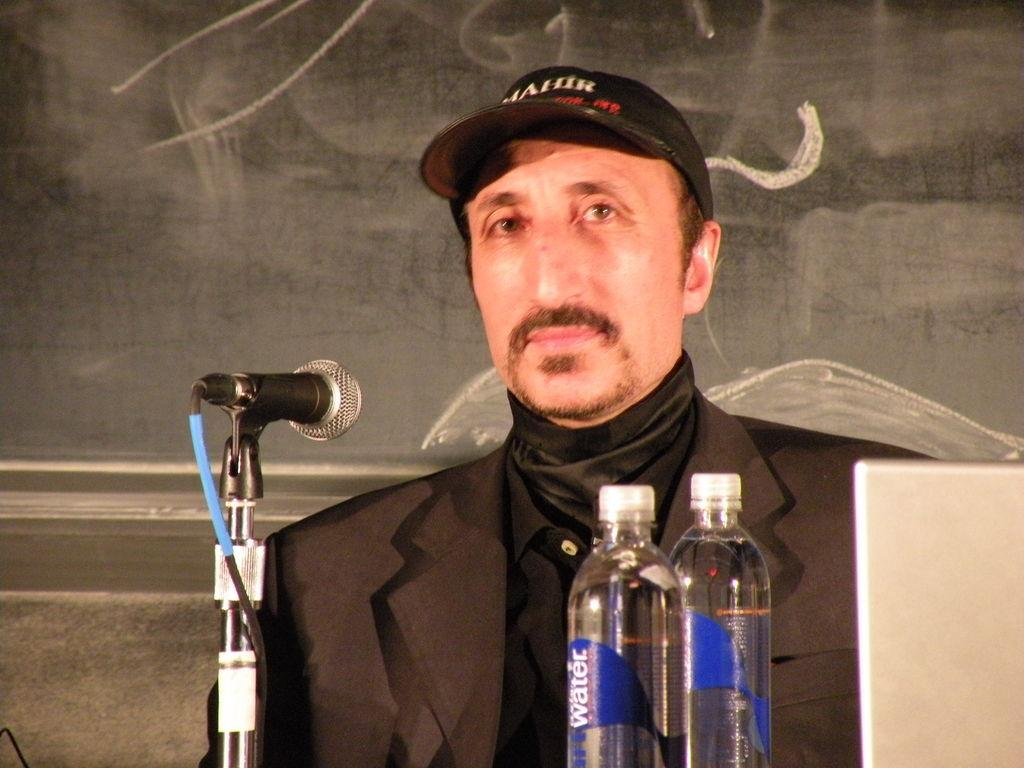Who is present in the image? There is a man in the image. What is the man wearing? The man is wearing a black suit and a cap. What object can be seen near the man? There is a microphone in the image. Are there any other items visible in the image? Yes, there are two bottles in the image. Can you see any wings on the man in the image? No, there are no wings visible on the man in the image. Is there a balloon floating above the man in the image? No, there is no balloon present in the image. 